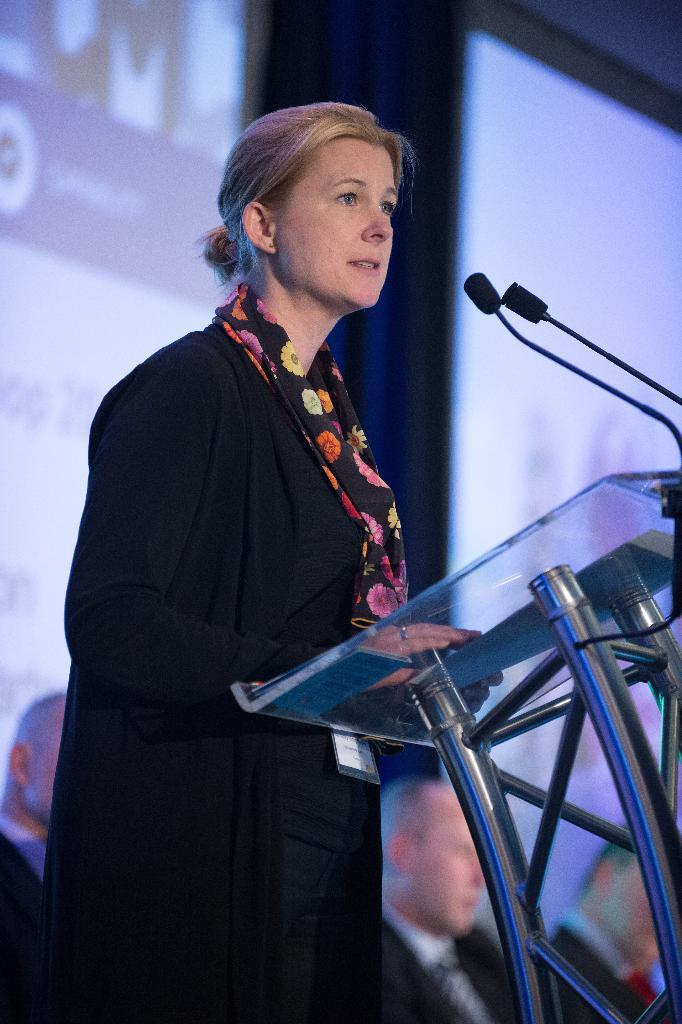Who is the main subject in the image? There is a woman in the image. What is the woman doing in the image? The woman is standing in front of a podium and speaking into a microphone. Who else is present in the image? There are people sitting behind the woman. What additional elements can be seen in the image? There are screens present in the image. How many quarters and dimes can be seen on the podium in the image? There are no quarters or dimes visible on the podium in the image. What type of help is the woman providing to the audience in the image? The image does not provide information about the specific help or assistance the woman is providing to the audience. 